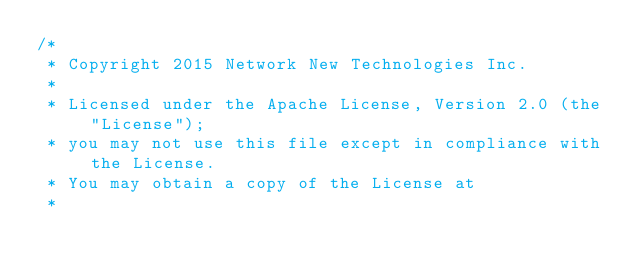<code> <loc_0><loc_0><loc_500><loc_500><_Java_>/*
 * Copyright 2015 Network New Technologies Inc.
 *
 * Licensed under the Apache License, Version 2.0 (the "License");
 * you may not use this file except in compliance with the License.
 * You may obtain a copy of the License at
 *</code> 